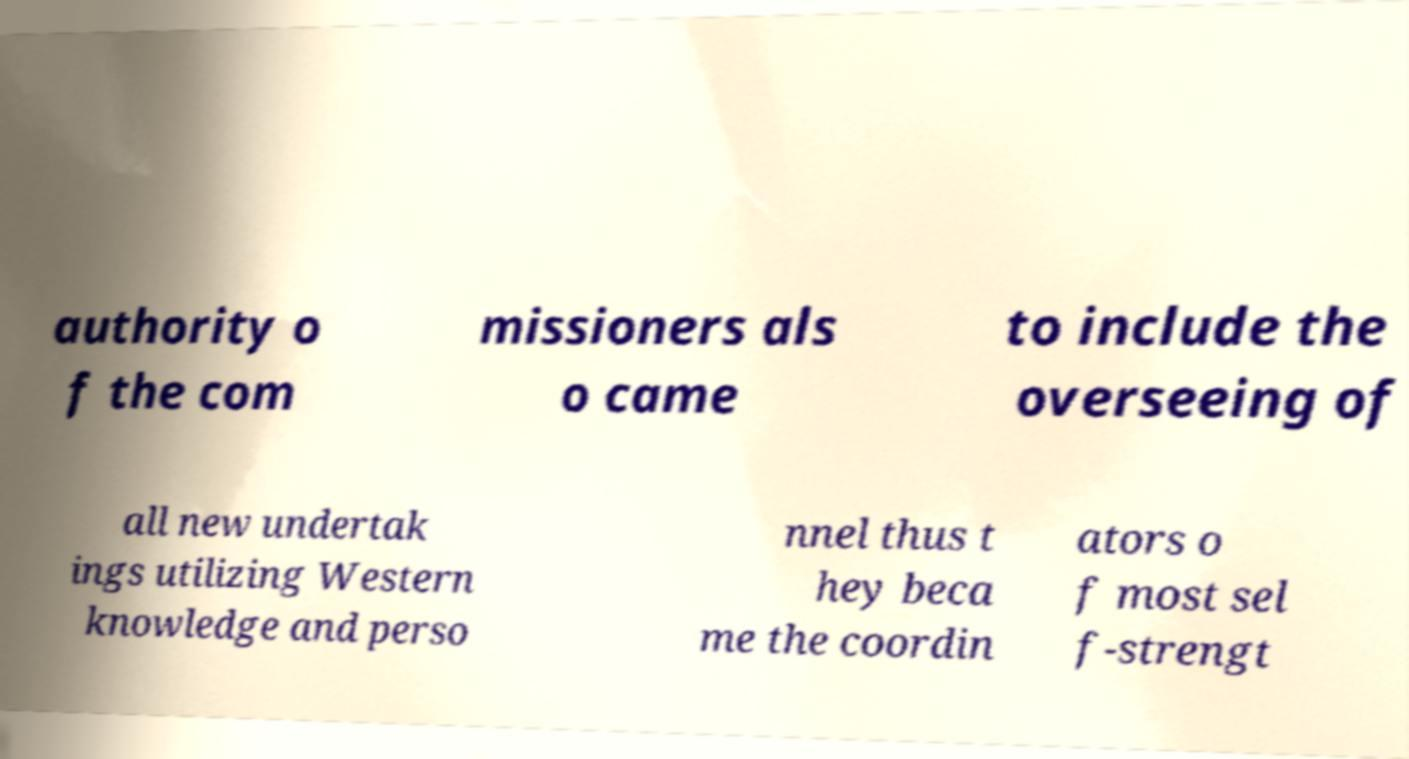Please read and relay the text visible in this image. What does it say? authority o f the com missioners als o came to include the overseeing of all new undertak ings utilizing Western knowledge and perso nnel thus t hey beca me the coordin ators o f most sel f-strengt 